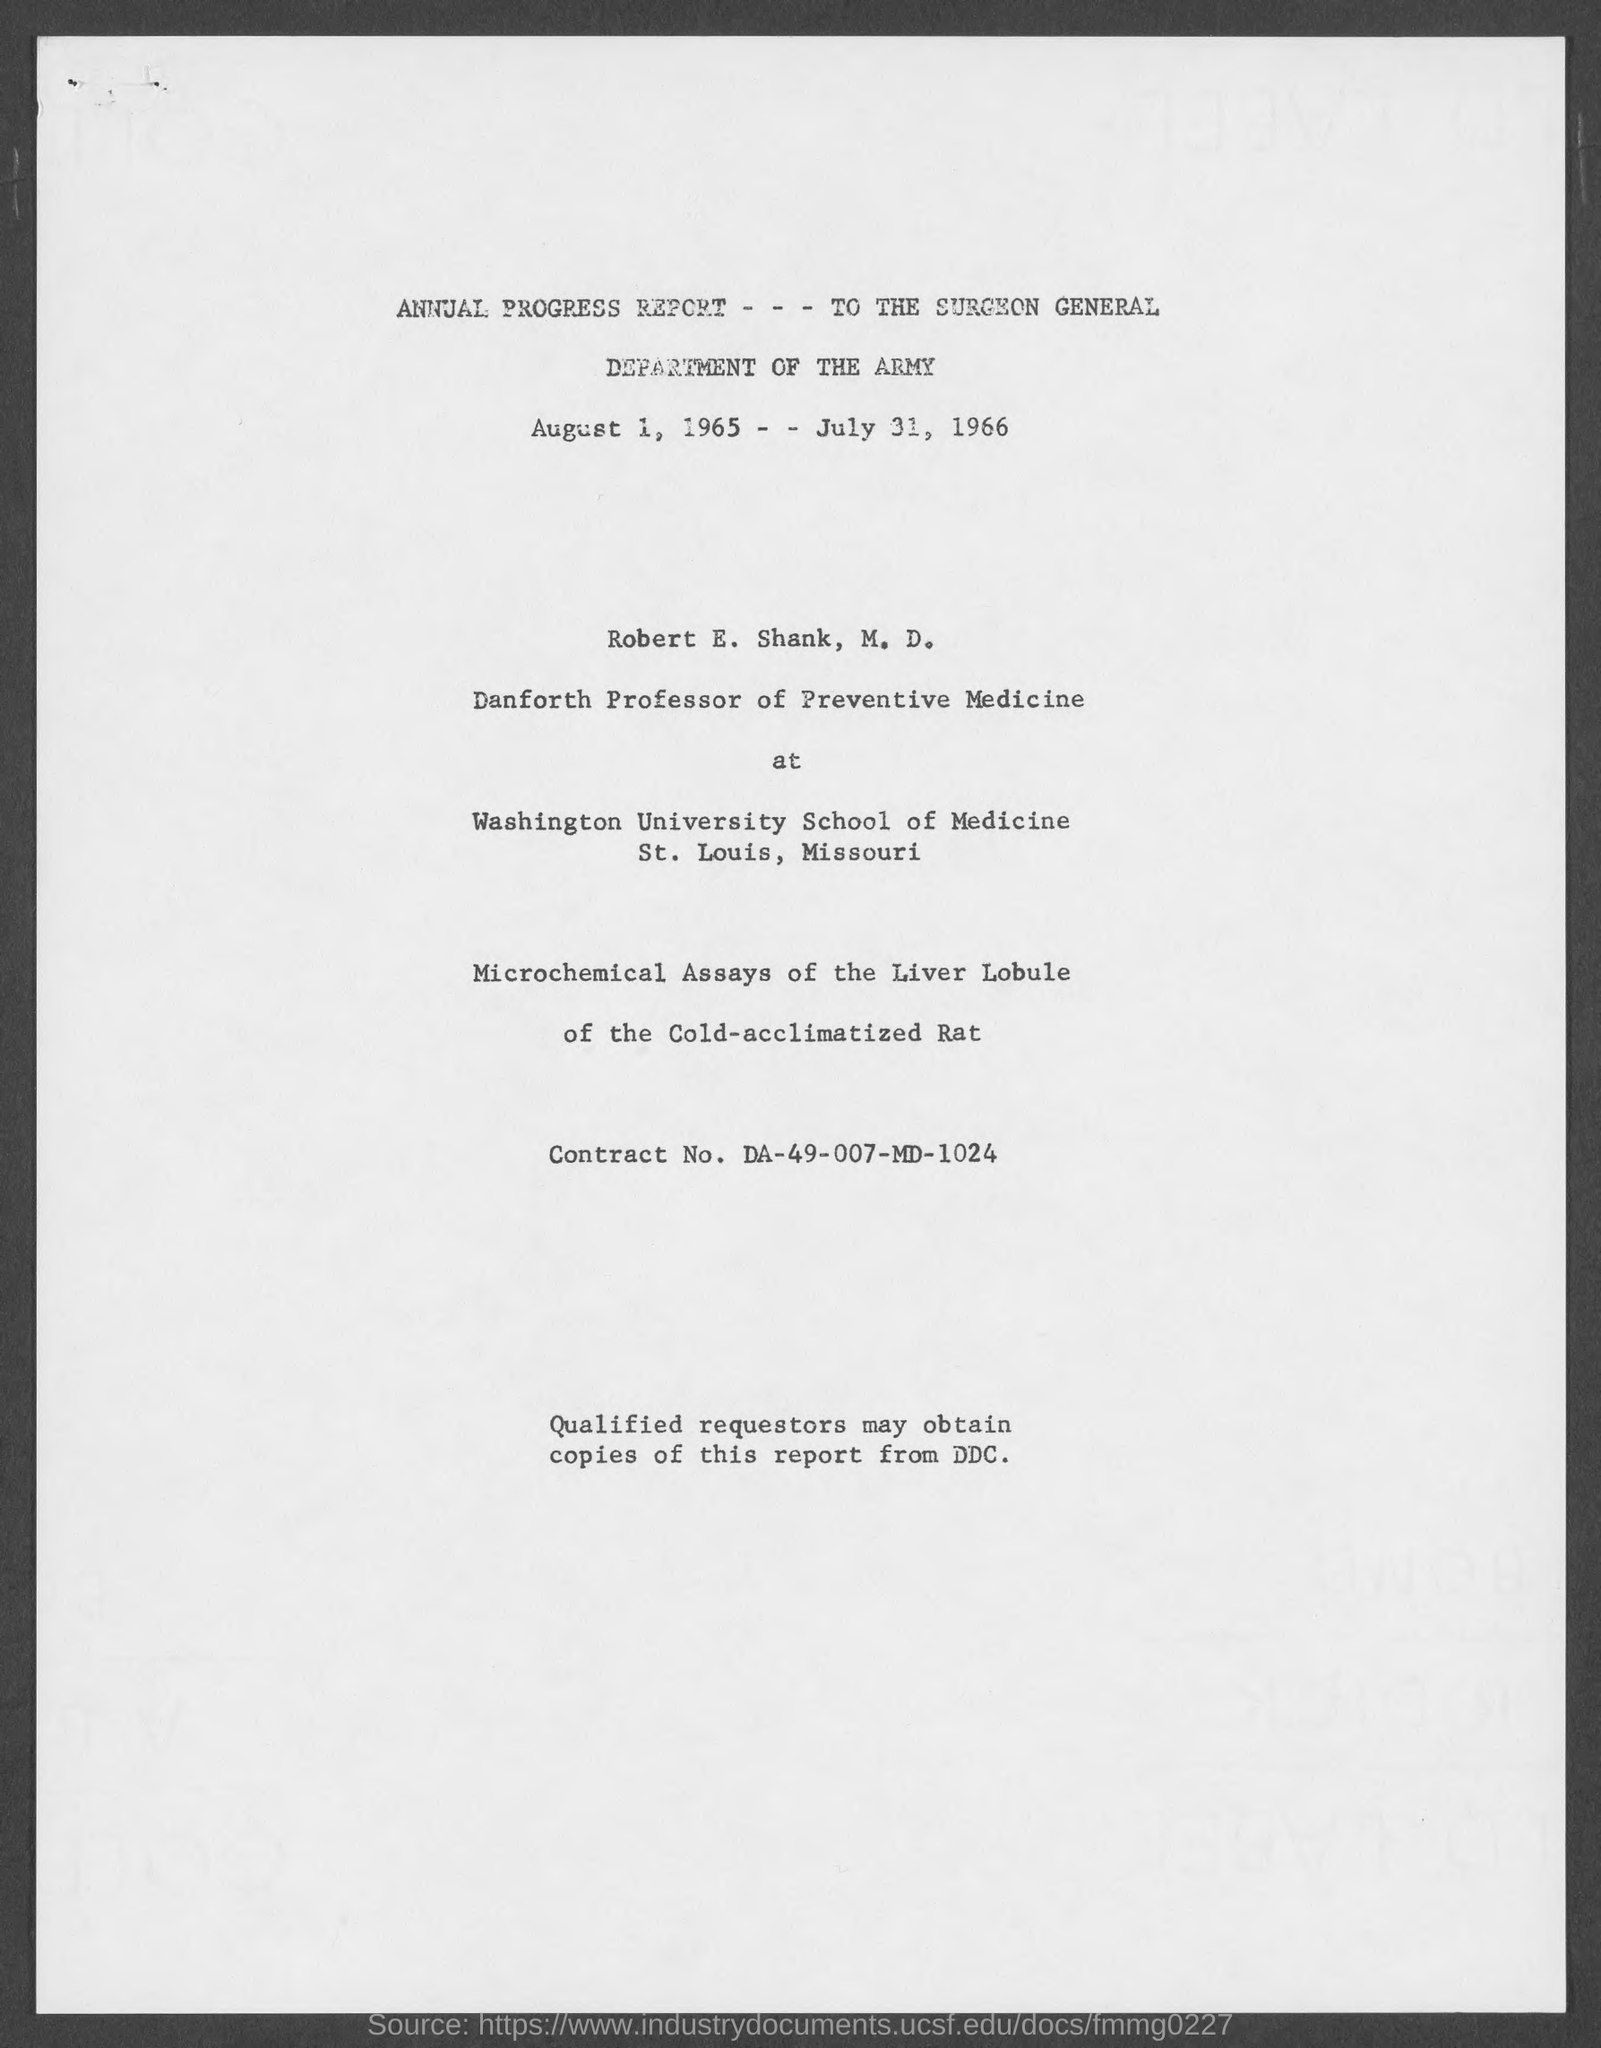Which year's annual progress report is given here?
Provide a succinct answer. August 1, 1965 - - July 31, 1966. Who is the Danforth Professor of Preventive Medicine at Washington School of Medicine?
Make the answer very short. Robert E. Shank, M.D. 